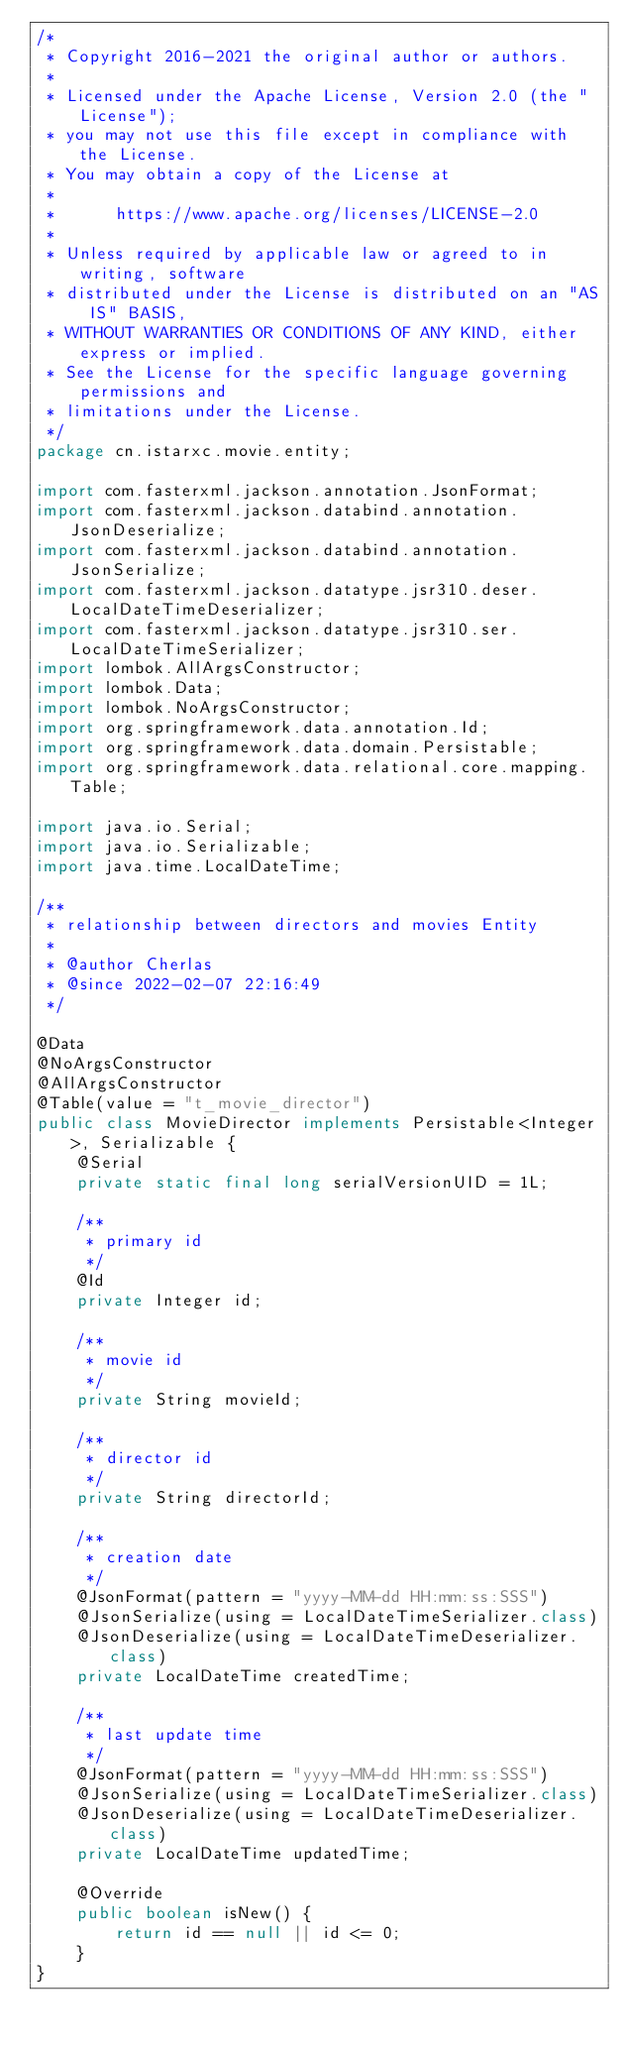<code> <loc_0><loc_0><loc_500><loc_500><_Java_>/*
 * Copyright 2016-2021 the original author or authors.
 *
 * Licensed under the Apache License, Version 2.0 (the "License");
 * you may not use this file except in compliance with the License.
 * You may obtain a copy of the License at
 *
 *      https://www.apache.org/licenses/LICENSE-2.0
 *
 * Unless required by applicable law or agreed to in writing, software
 * distributed under the License is distributed on an "AS IS" BASIS,
 * WITHOUT WARRANTIES OR CONDITIONS OF ANY KIND, either express or implied.
 * See the License for the specific language governing permissions and
 * limitations under the License.
 */
package cn.istarxc.movie.entity;

import com.fasterxml.jackson.annotation.JsonFormat;
import com.fasterxml.jackson.databind.annotation.JsonDeserialize;
import com.fasterxml.jackson.databind.annotation.JsonSerialize;
import com.fasterxml.jackson.datatype.jsr310.deser.LocalDateTimeDeserializer;
import com.fasterxml.jackson.datatype.jsr310.ser.LocalDateTimeSerializer;
import lombok.AllArgsConstructor;
import lombok.Data;
import lombok.NoArgsConstructor;
import org.springframework.data.annotation.Id;
import org.springframework.data.domain.Persistable;
import org.springframework.data.relational.core.mapping.Table;

import java.io.Serial;
import java.io.Serializable;
import java.time.LocalDateTime;

/**
 * relationship between directors and movies Entity
 *
 * @author Cherlas
 * @since 2022-02-07 22:16:49
 */

@Data
@NoArgsConstructor
@AllArgsConstructor
@Table(value = "t_movie_director")
public class MovieDirector implements Persistable<Integer>, Serializable {
    @Serial
    private static final long serialVersionUID = 1L;

    /**
     * primary id
     */
    @Id
    private Integer id;

    /**
     * movie id
     */
    private String movieId;

    /**
     * director id
     */
    private String directorId;

    /**
     * creation date
     */
    @JsonFormat(pattern = "yyyy-MM-dd HH:mm:ss:SSS")
    @JsonSerialize(using = LocalDateTimeSerializer.class)
    @JsonDeserialize(using = LocalDateTimeDeserializer.class)
    private LocalDateTime createdTime;

    /**
     * last update time
     */
    @JsonFormat(pattern = "yyyy-MM-dd HH:mm:ss:SSS")
    @JsonSerialize(using = LocalDateTimeSerializer.class)
    @JsonDeserialize(using = LocalDateTimeDeserializer.class)
    private LocalDateTime updatedTime;

    @Override
    public boolean isNew() {
        return id == null || id <= 0;
    }
}

</code> 